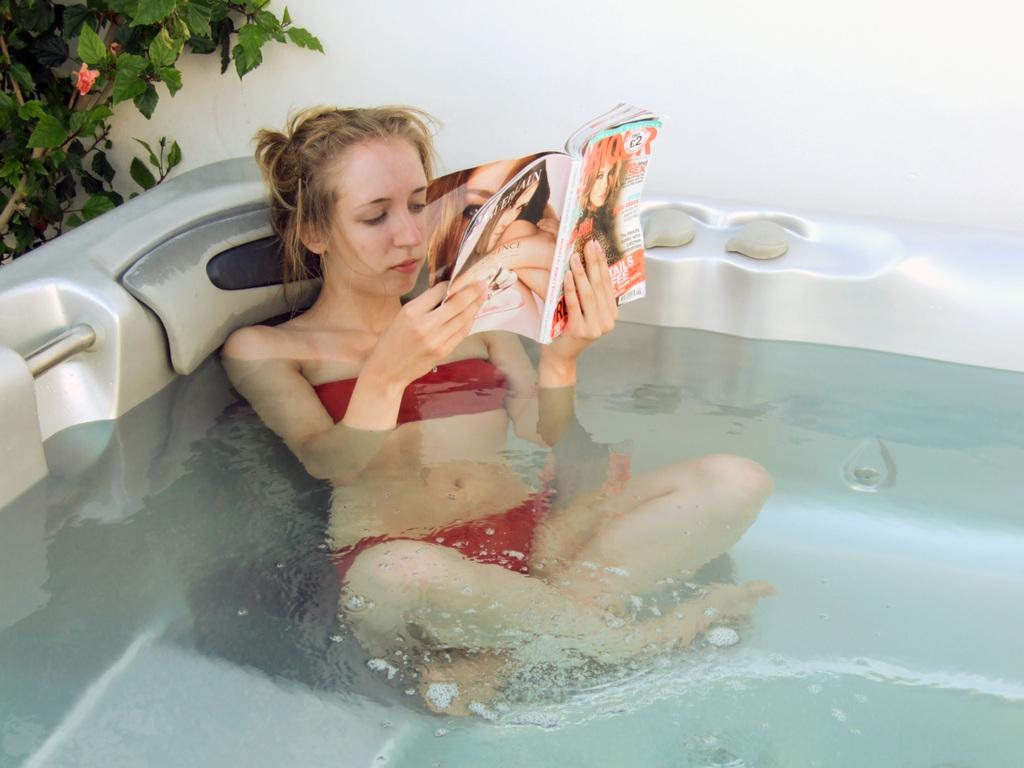Describe this image in one or two sentences. In this picture, we see a woman is sitting in the bathtub containing the water. She is holding the book in her hands and she is reading the book. In the left top, we see a plant which has a pink flower. In the background, we see a white wall. 